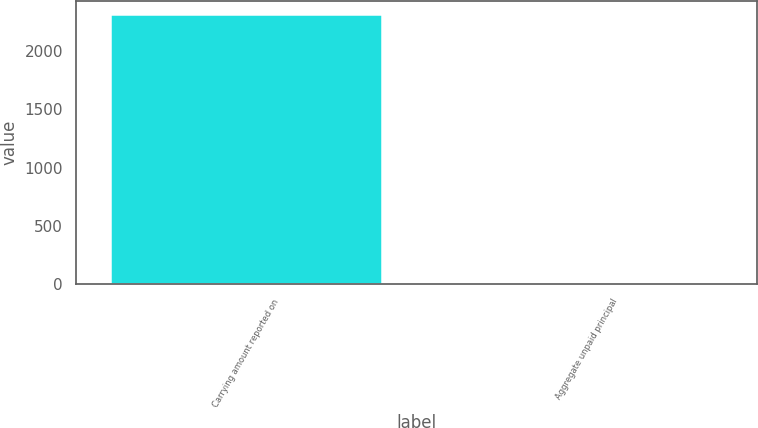<chart> <loc_0><loc_0><loc_500><loc_500><bar_chart><fcel>Carrying amount reported on<fcel>Aggregate unpaid principal<nl><fcel>2315<fcel>3<nl></chart> 